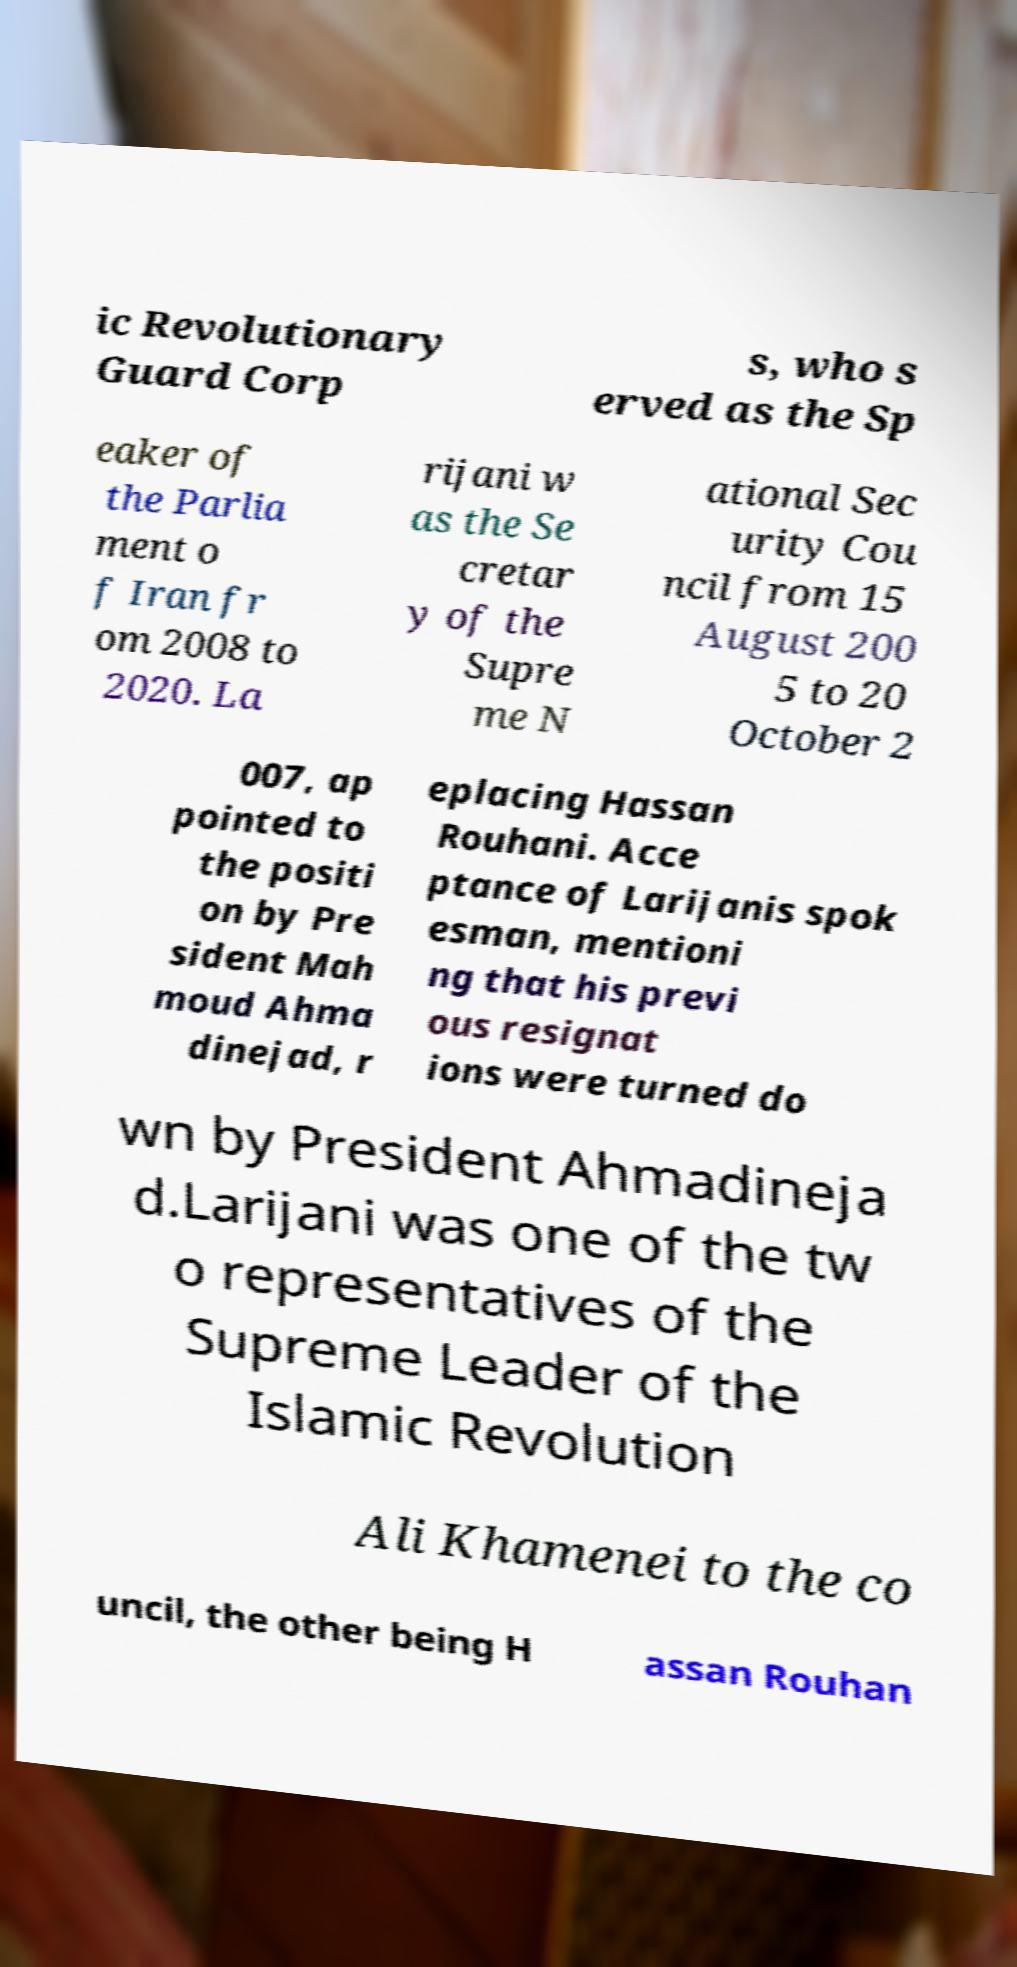Could you assist in decoding the text presented in this image and type it out clearly? ic Revolutionary Guard Corp s, who s erved as the Sp eaker of the Parlia ment o f Iran fr om 2008 to 2020. La rijani w as the Se cretar y of the Supre me N ational Sec urity Cou ncil from 15 August 200 5 to 20 October 2 007, ap pointed to the positi on by Pre sident Mah moud Ahma dinejad, r eplacing Hassan Rouhani. Acce ptance of Larijanis spok esman, mentioni ng that his previ ous resignat ions were turned do wn by President Ahmadineja d.Larijani was one of the tw o representatives of the Supreme Leader of the Islamic Revolution Ali Khamenei to the co uncil, the other being H assan Rouhan 